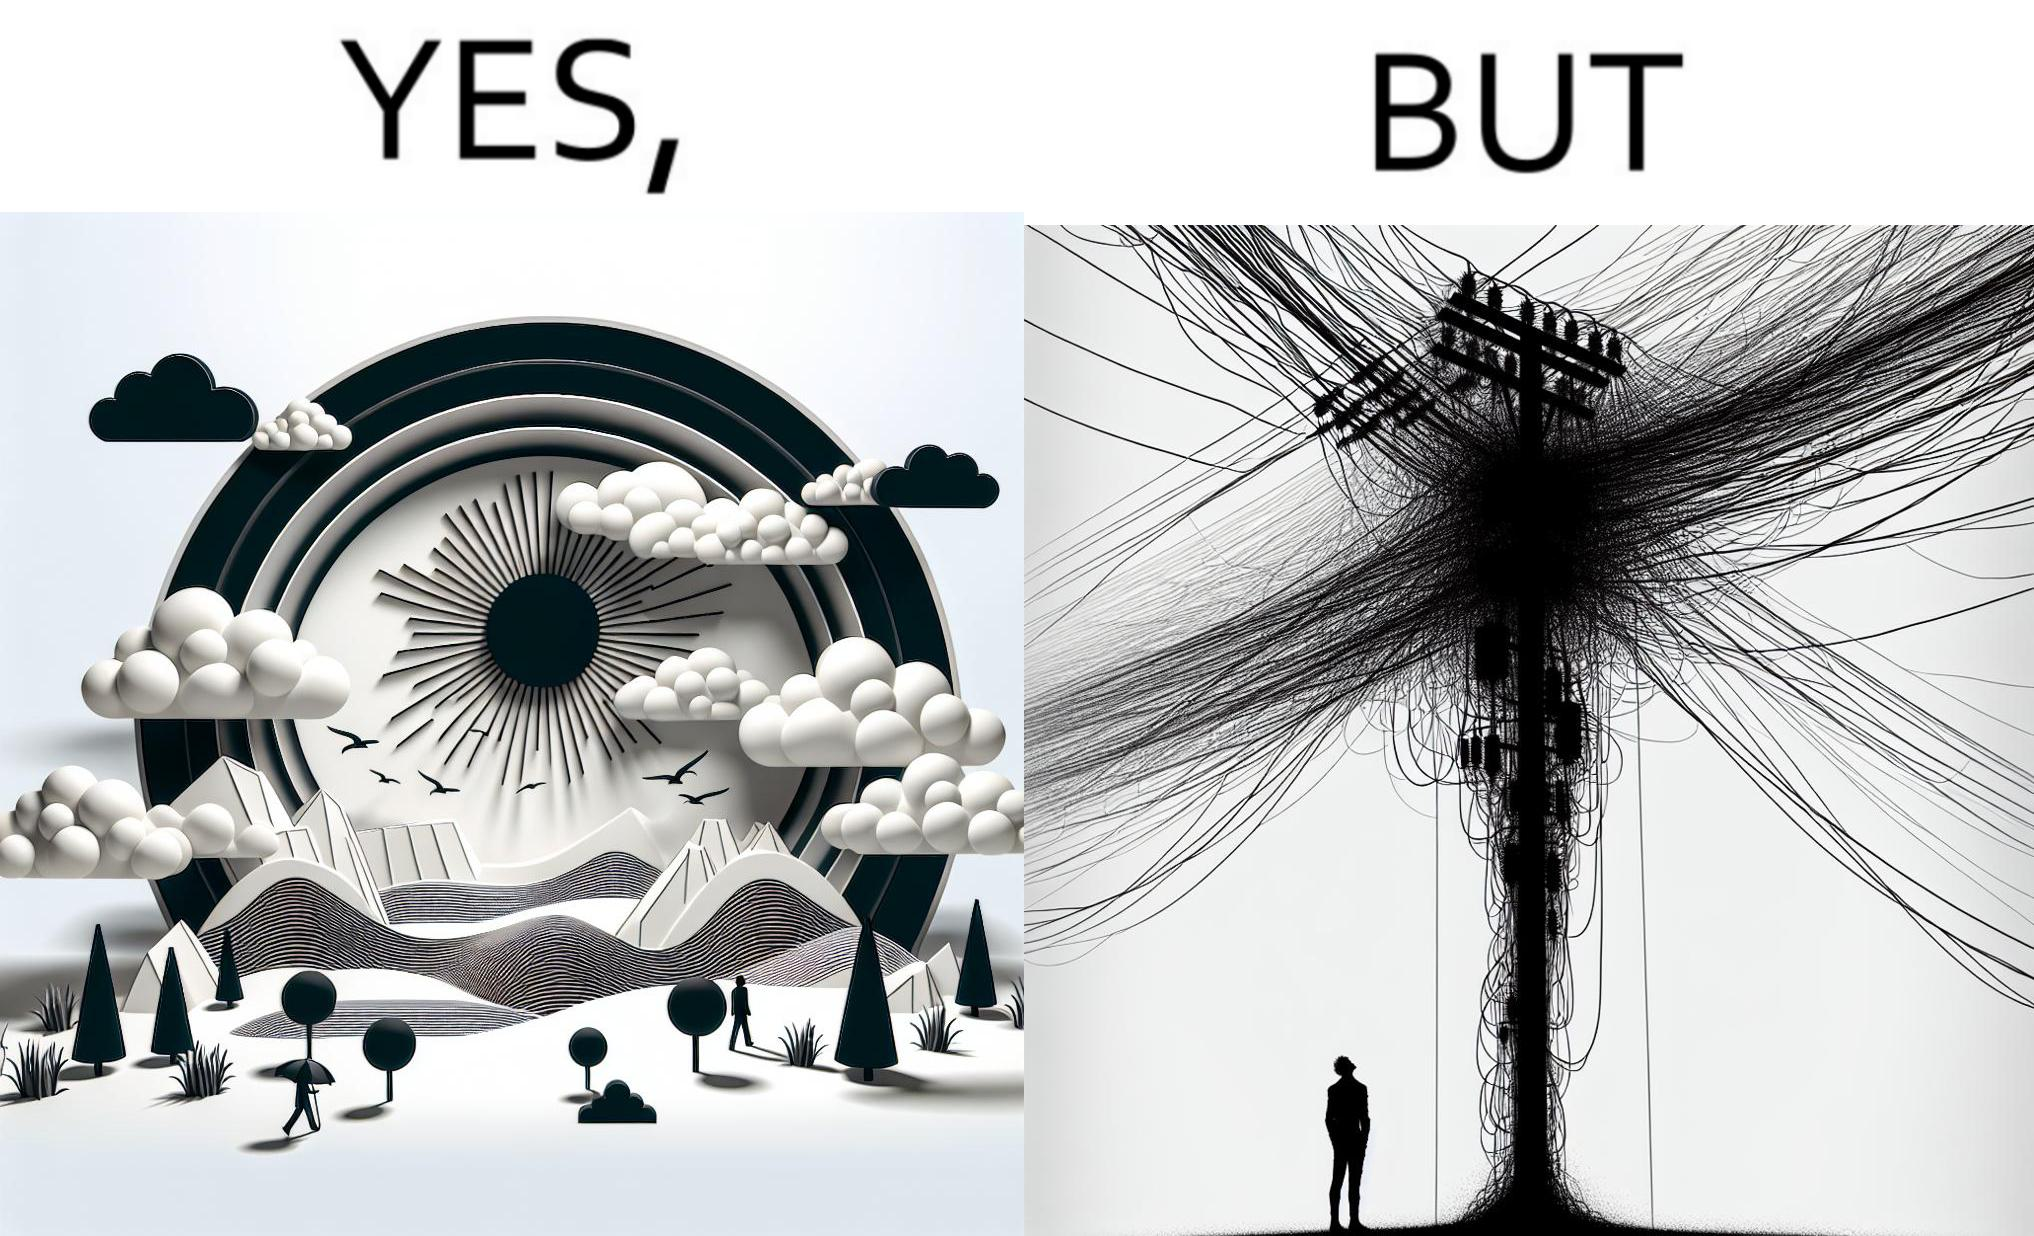Is this a satirical image? Yes, this image is satirical. 